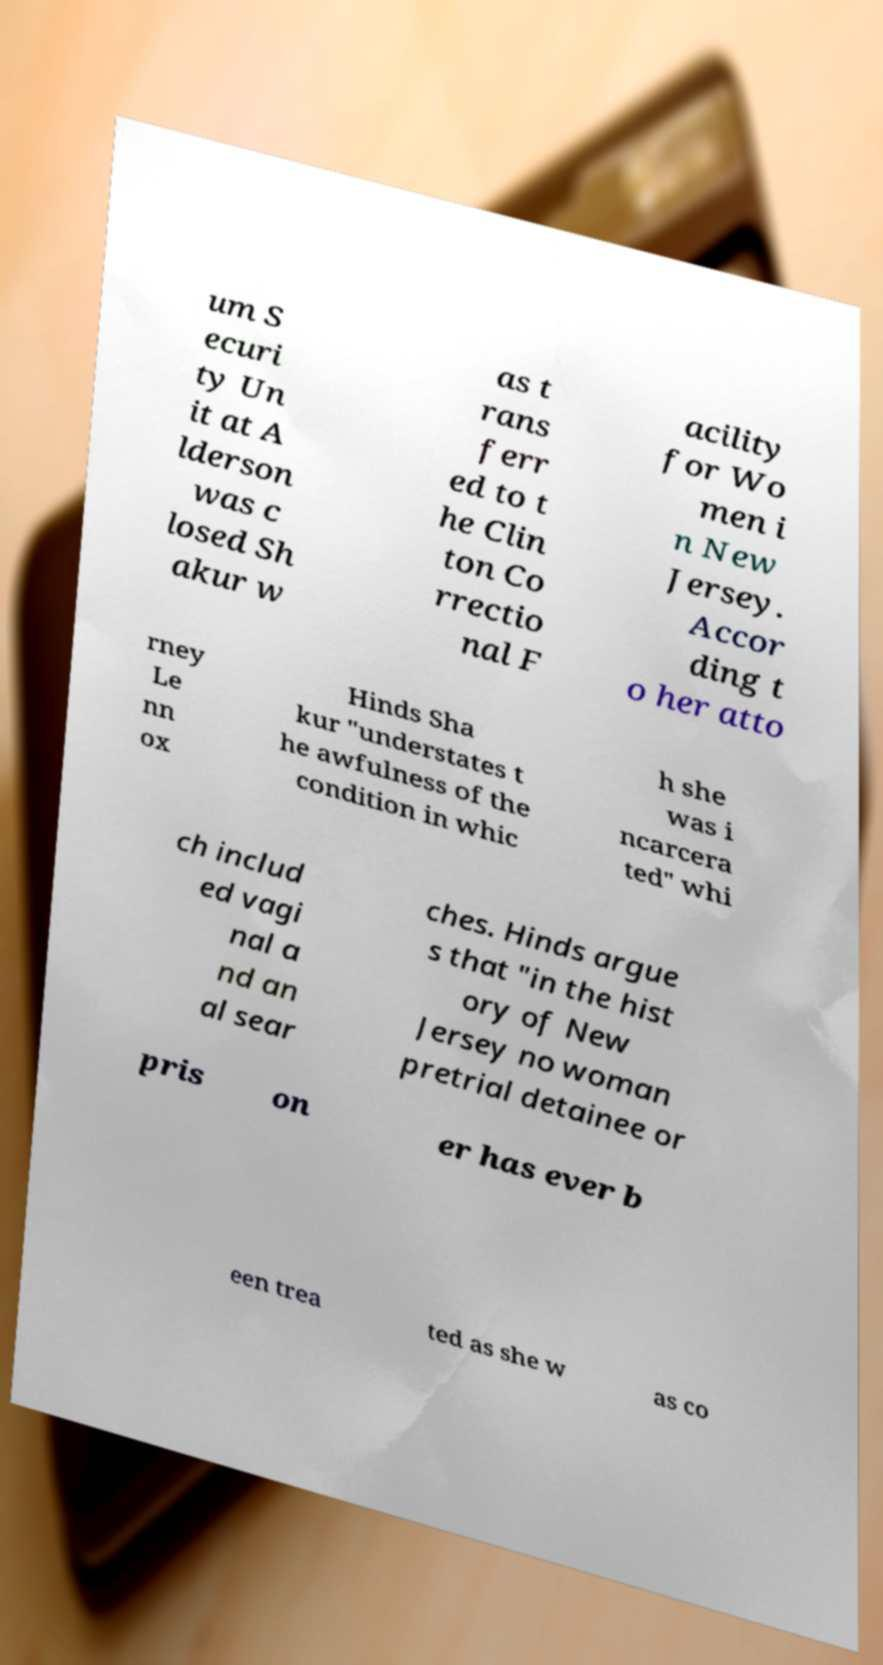There's text embedded in this image that I need extracted. Can you transcribe it verbatim? um S ecuri ty Un it at A lderson was c losed Sh akur w as t rans ferr ed to t he Clin ton Co rrectio nal F acility for Wo men i n New Jersey. Accor ding t o her atto rney Le nn ox Hinds Sha kur "understates t he awfulness of the condition in whic h she was i ncarcera ted" whi ch includ ed vagi nal a nd an al sear ches. Hinds argue s that "in the hist ory of New Jersey no woman pretrial detainee or pris on er has ever b een trea ted as she w as co 